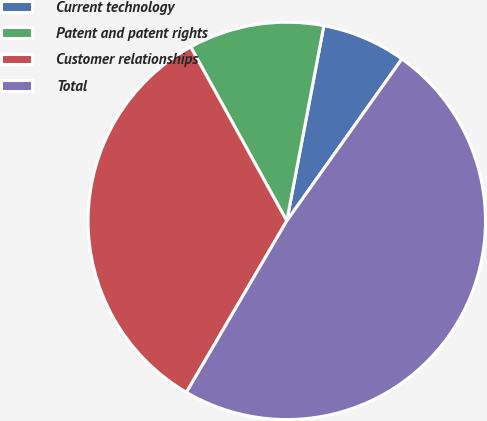<chart> <loc_0><loc_0><loc_500><loc_500><pie_chart><fcel>Current technology<fcel>Patent and patent rights<fcel>Customer relationships<fcel>Total<nl><fcel>6.85%<fcel>11.02%<fcel>33.54%<fcel>48.59%<nl></chart> 